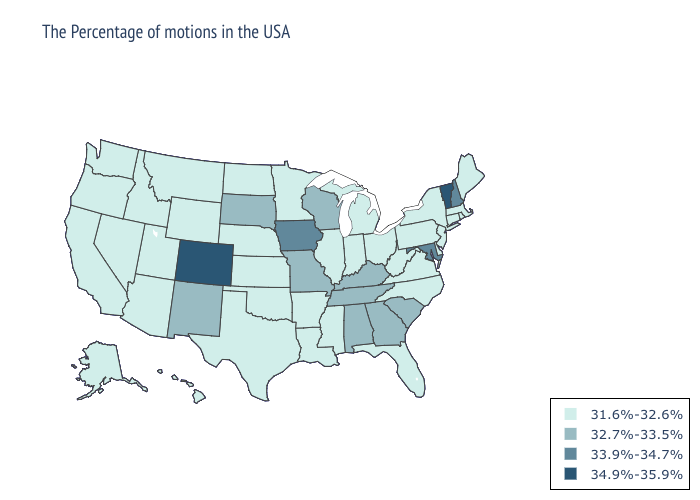Does Ohio have the highest value in the MidWest?
Concise answer only. No. Among the states that border Tennessee , does Mississippi have the highest value?
Keep it brief. No. What is the lowest value in the South?
Be succinct. 31.6%-32.6%. Among the states that border Maine , which have the highest value?
Concise answer only. New Hampshire. Does the first symbol in the legend represent the smallest category?
Short answer required. Yes. Does Utah have the highest value in the USA?
Short answer required. No. Does Montana have a lower value than Georgia?
Keep it brief. Yes. Among the states that border Kentucky , which have the highest value?
Concise answer only. Tennessee, Missouri. Name the states that have a value in the range 32.7%-33.5%?
Short answer required. South Carolina, Georgia, Kentucky, Alabama, Tennessee, Wisconsin, Missouri, South Dakota, New Mexico. What is the value of Hawaii?
Write a very short answer. 31.6%-32.6%. Does New Hampshire have the highest value in the Northeast?
Be succinct. No. What is the value of Vermont?
Write a very short answer. 34.9%-35.9%. What is the highest value in the USA?
Keep it brief. 34.9%-35.9%. Name the states that have a value in the range 31.6%-32.6%?
Answer briefly. Maine, Massachusetts, Rhode Island, Connecticut, New York, New Jersey, Delaware, Pennsylvania, Virginia, North Carolina, West Virginia, Ohio, Florida, Michigan, Indiana, Illinois, Mississippi, Louisiana, Arkansas, Minnesota, Kansas, Nebraska, Oklahoma, Texas, North Dakota, Wyoming, Utah, Montana, Arizona, Idaho, Nevada, California, Washington, Oregon, Alaska, Hawaii. Does the map have missing data?
Write a very short answer. No. 